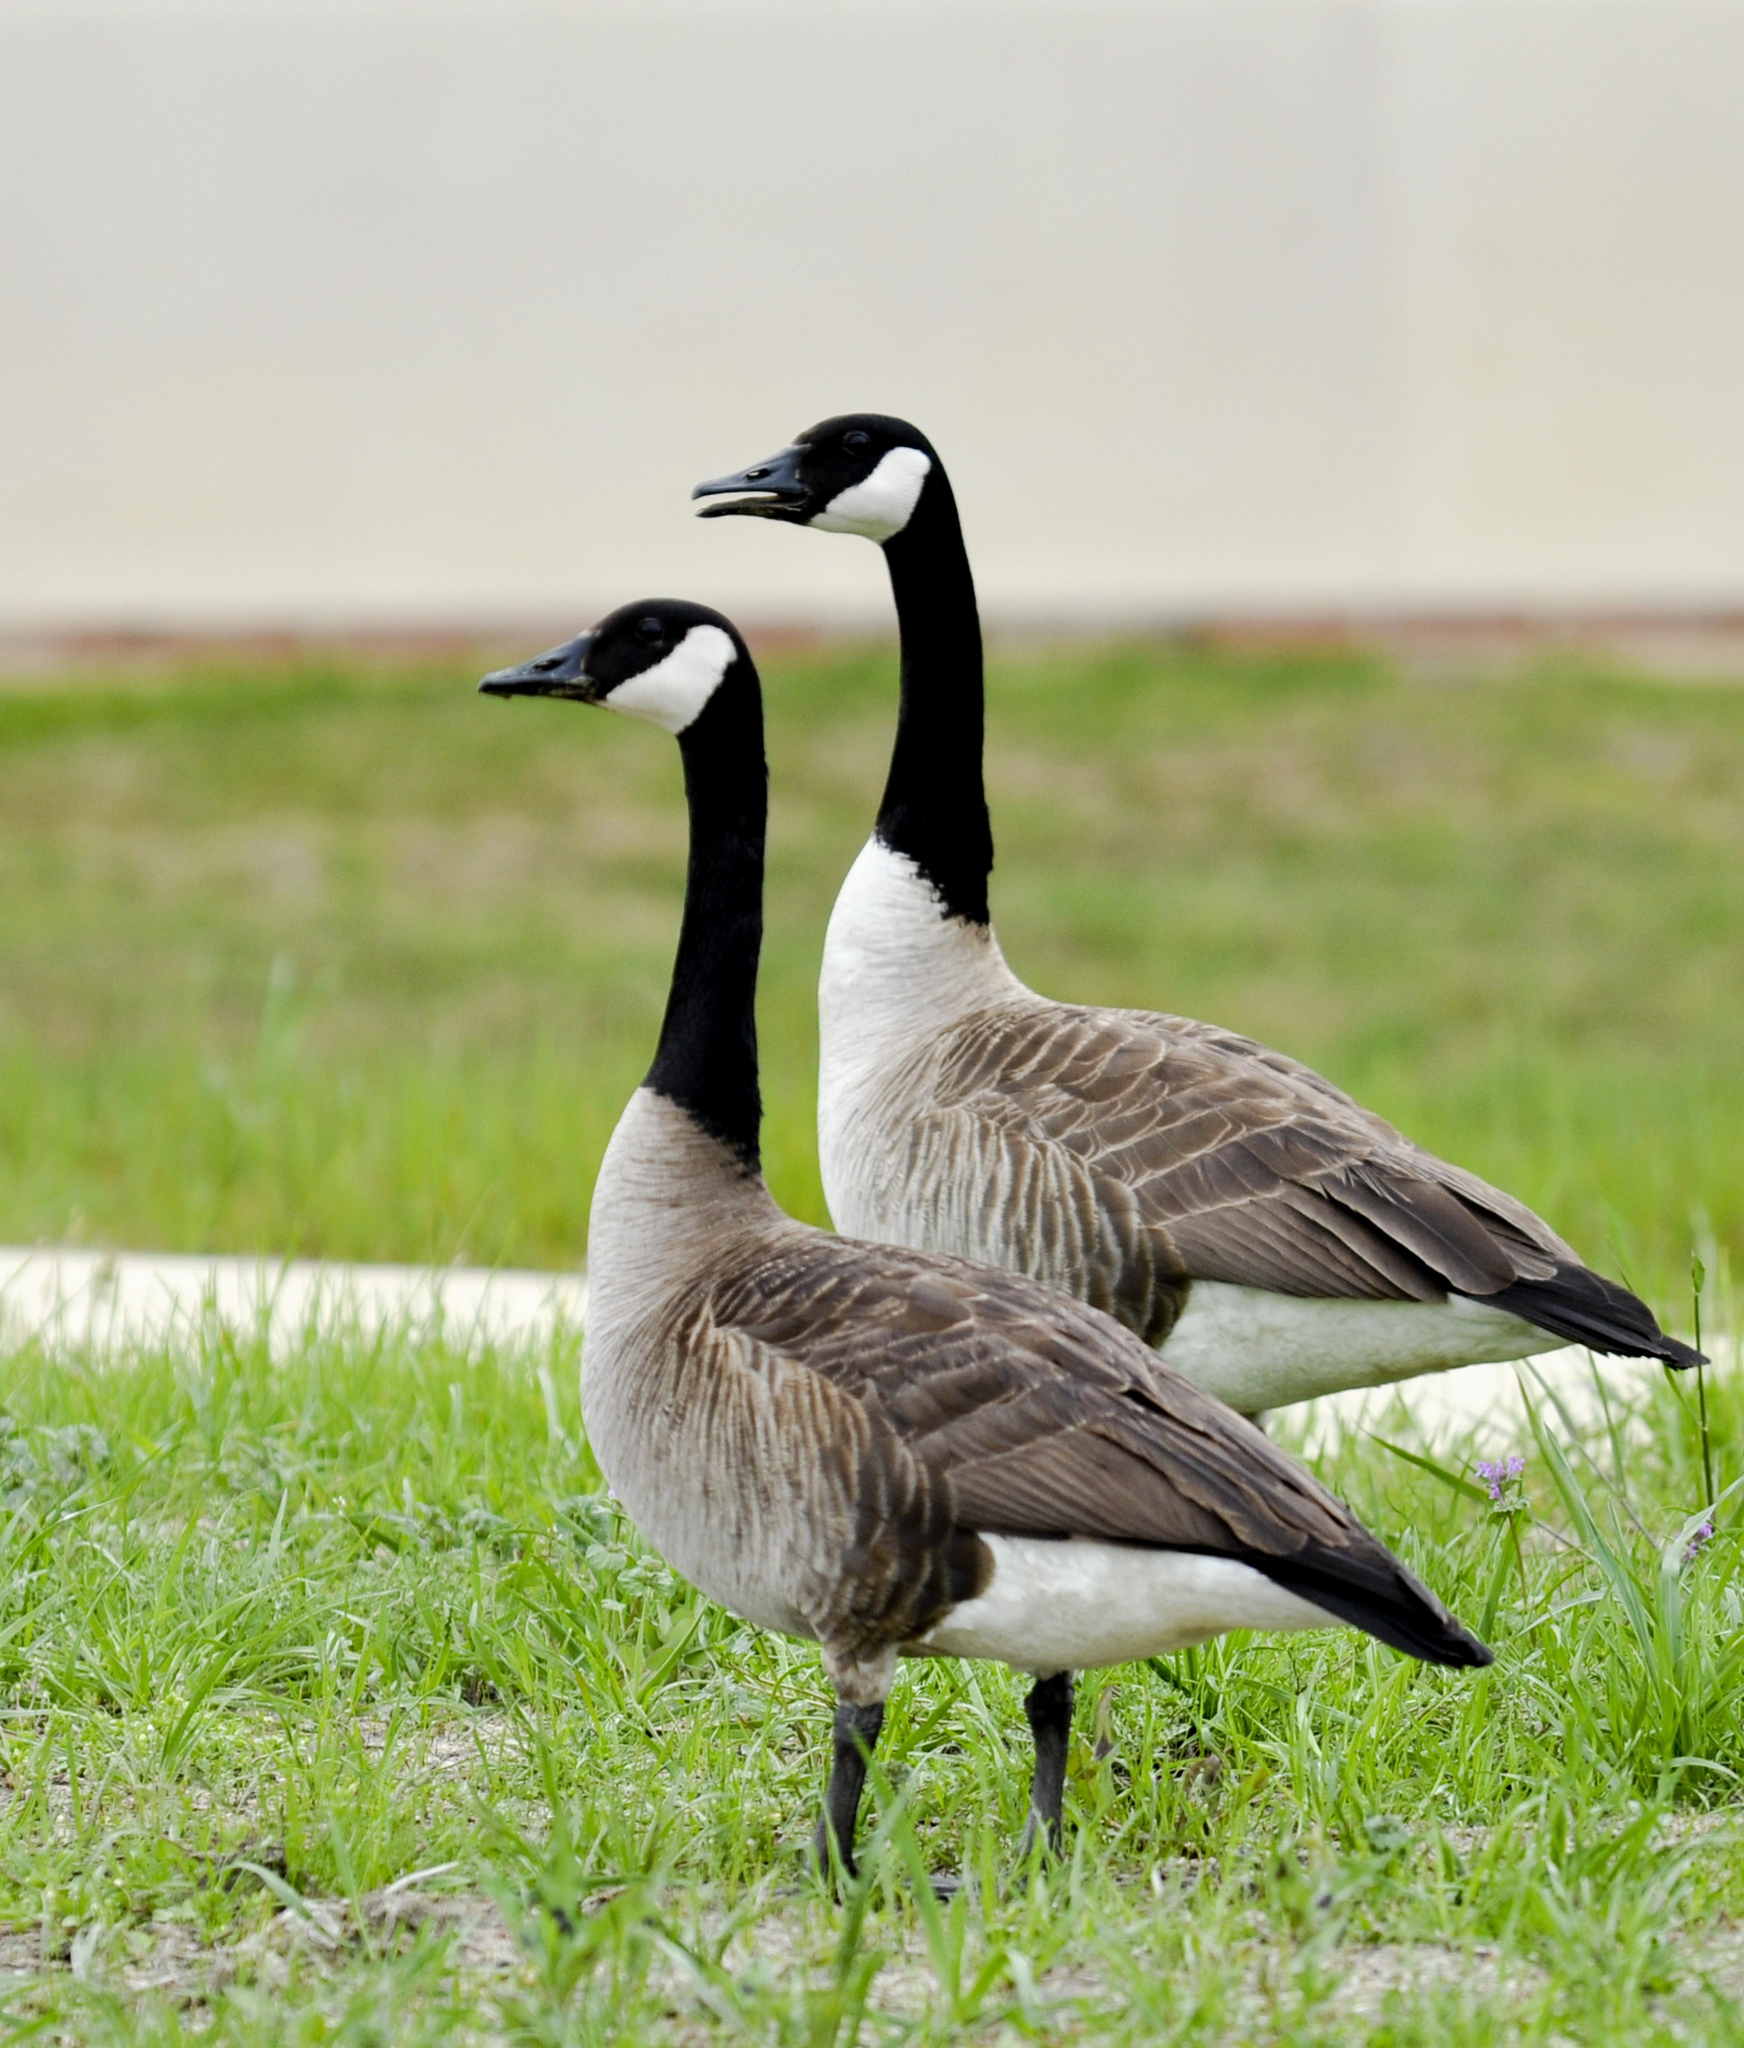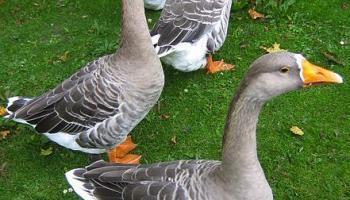The first image is the image on the left, the second image is the image on the right. Considering the images on both sides, is "An image includes at least one long-necked goose with a black neck, and the goose is upright on the grass." valid? Answer yes or no. Yes. The first image is the image on the left, the second image is the image on the right. Analyze the images presented: Is the assertion "One of the images show geese that are all facing left." valid? Answer yes or no. Yes. 